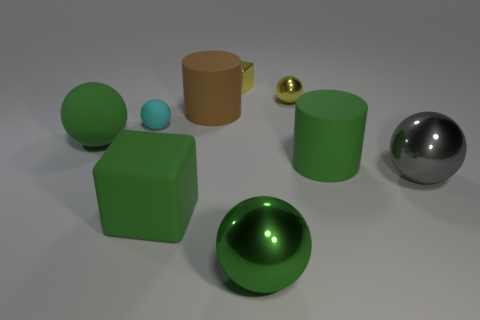How does the lighting in the scene affect the appearance of the objects? The diffuse overhead lighting in the scene produces soft shadows and highlights that accentuate the forms of the objects. It enhances the texture of the matte surfaces, such as the block and the cup, while it vividly reflects off the shiny spheres, giving them a sense of depth and dimensionality. 